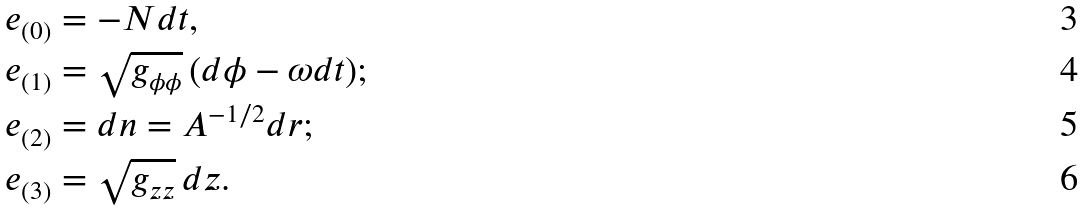<formula> <loc_0><loc_0><loc_500><loc_500>e _ { ( 0 ) } & = - N d t , \\ e _ { ( 1 ) } & = \sqrt { g _ { \phi \phi } } \, ( d \phi - \omega d t ) ; \\ e _ { ( 2 ) } & = d n = A ^ { - 1 / 2 } d r ; \\ e _ { ( 3 ) } & = \sqrt { g _ { z z } } \, d z .</formula> 